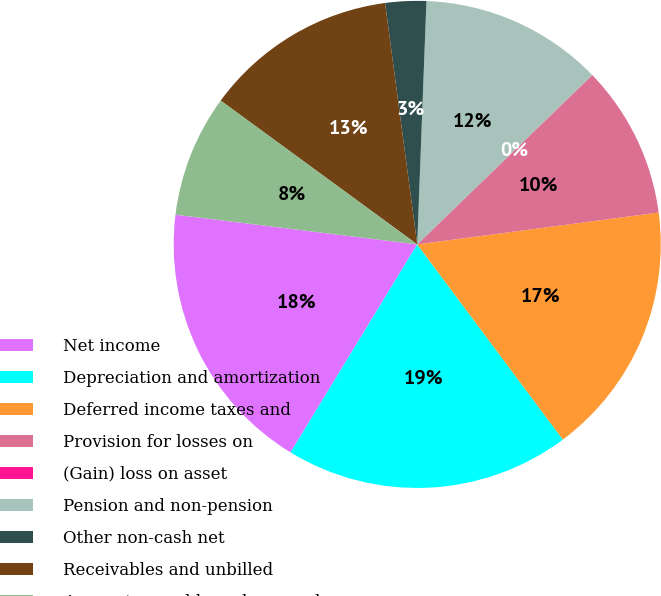Convert chart. <chart><loc_0><loc_0><loc_500><loc_500><pie_chart><fcel>Net income<fcel>Depreciation and amortization<fcel>Deferred income taxes and<fcel>Provision for losses on<fcel>(Gain) loss on asset<fcel>Pension and non-pension<fcel>Other non-cash net<fcel>Receivables and unbilled<fcel>Accounts payable and accrued<nl><fcel>18.24%<fcel>18.91%<fcel>16.89%<fcel>10.14%<fcel>0.01%<fcel>12.16%<fcel>2.71%<fcel>12.84%<fcel>8.11%<nl></chart> 